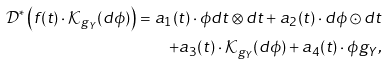<formula> <loc_0><loc_0><loc_500><loc_500>\mathcal { D } ^ { * } \left ( f ( t ) \cdot \mathcal { K } _ { g _ { Y } } ( d \phi ) \right ) = a _ { 1 } ( t ) \cdot \phi d t \otimes d t + a _ { 2 } ( t ) \cdot d \phi \odot d t \\ + a _ { 3 } ( t ) \cdot \mathcal { K } _ { g _ { Y } } ( d \phi ) + a _ { 4 } ( t ) \cdot \phi g _ { Y } ,</formula> 